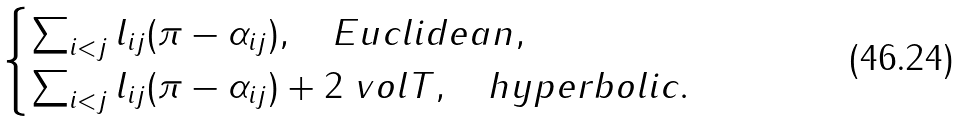Convert formula to latex. <formula><loc_0><loc_0><loc_500><loc_500>\begin{cases} \sum _ { i < j } l _ { i j } ( \pi - \alpha _ { i j } ) , \quad E u c l i d e a n , \\ \sum _ { i < j } l _ { i j } ( \pi - \alpha _ { i j } ) + 2 \ v o l T , \quad h y p e r b o l i c . \end{cases}</formula> 